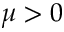Convert formula to latex. <formula><loc_0><loc_0><loc_500><loc_500>\mu > 0</formula> 